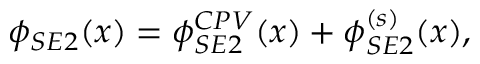Convert formula to latex. <formula><loc_0><loc_0><loc_500><loc_500>\phi _ { S E 2 } ( x ) = \phi _ { S E 2 } ^ { C P V } ( x ) + \phi _ { S E 2 } ^ { ( s ) } ( x ) ,</formula> 